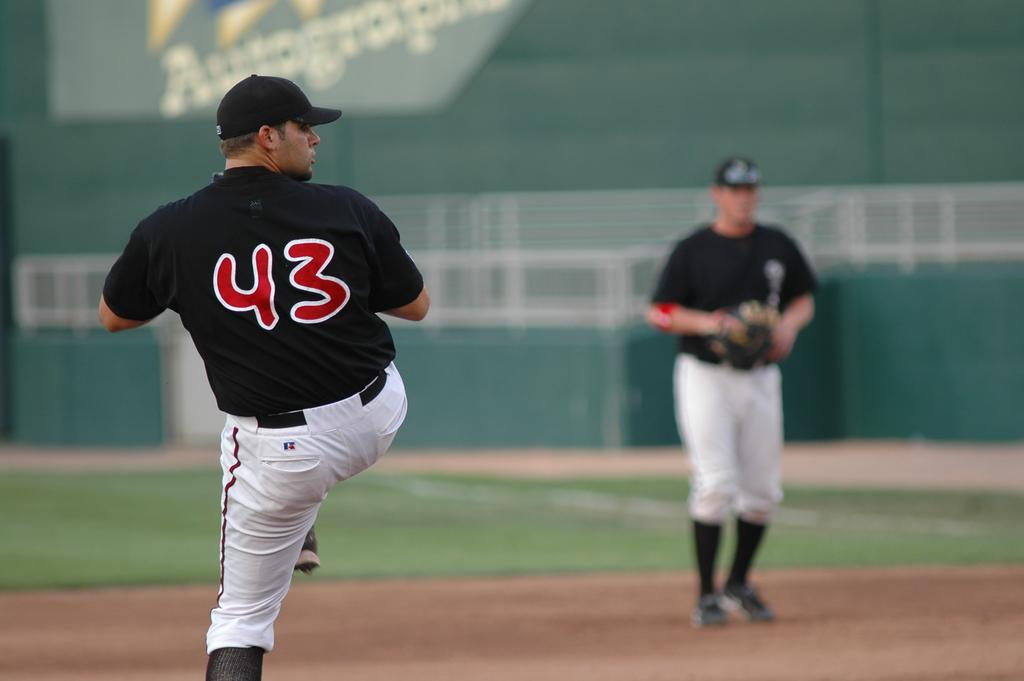<image>
Summarize the visual content of the image. A player sporting number 43 on his uniform winds up to throw a ball. 